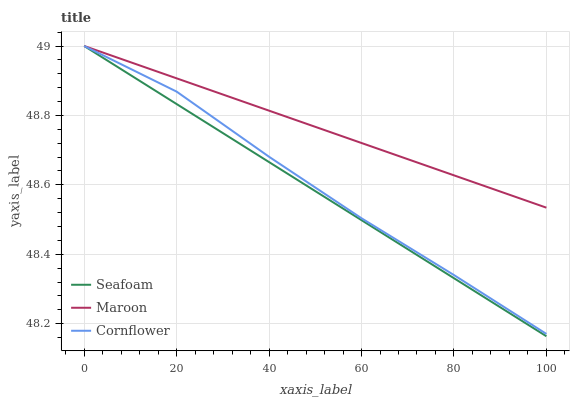Does Seafoam have the minimum area under the curve?
Answer yes or no. Yes. Does Maroon have the maximum area under the curve?
Answer yes or no. Yes. Does Maroon have the minimum area under the curve?
Answer yes or no. No. Does Seafoam have the maximum area under the curve?
Answer yes or no. No. Is Seafoam the smoothest?
Answer yes or no. Yes. Is Cornflower the roughest?
Answer yes or no. Yes. Is Maroon the smoothest?
Answer yes or no. No. Is Maroon the roughest?
Answer yes or no. No. Does Maroon have the lowest value?
Answer yes or no. No. Does Maroon have the highest value?
Answer yes or no. Yes. Does Maroon intersect Cornflower?
Answer yes or no. Yes. Is Maroon less than Cornflower?
Answer yes or no. No. Is Maroon greater than Cornflower?
Answer yes or no. No. 